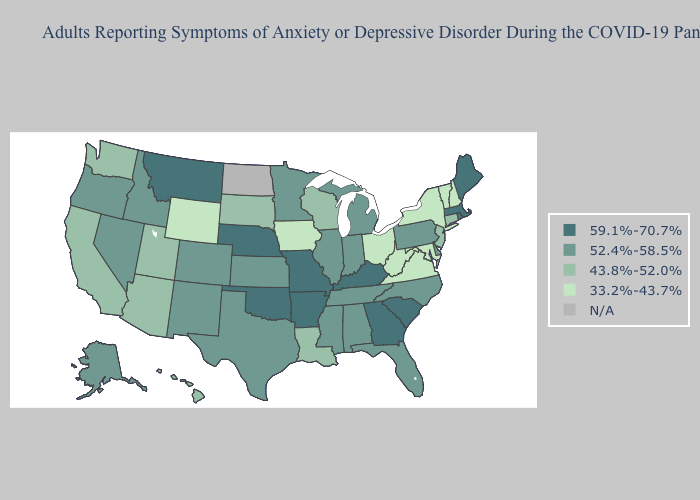What is the value of Florida?
Answer briefly. 52.4%-58.5%. What is the lowest value in the USA?
Concise answer only. 33.2%-43.7%. Does the map have missing data?
Concise answer only. Yes. Does Rhode Island have the highest value in the Northeast?
Short answer required. Yes. Among the states that border Maryland , does Delaware have the lowest value?
Concise answer only. No. Which states have the lowest value in the USA?
Answer briefly. Iowa, Maryland, New Hampshire, New York, Ohio, Vermont, Virginia, West Virginia, Wyoming. What is the value of Tennessee?
Short answer required. 52.4%-58.5%. What is the highest value in the USA?
Quick response, please. 59.1%-70.7%. What is the lowest value in the Northeast?
Give a very brief answer. 33.2%-43.7%. Which states have the lowest value in the USA?
Short answer required. Iowa, Maryland, New Hampshire, New York, Ohio, Vermont, Virginia, West Virginia, Wyoming. What is the lowest value in states that border Connecticut?
Answer briefly. 33.2%-43.7%. What is the highest value in the USA?
Give a very brief answer. 59.1%-70.7%. Name the states that have a value in the range 59.1%-70.7%?
Concise answer only. Arkansas, Georgia, Kentucky, Maine, Massachusetts, Missouri, Montana, Nebraska, Oklahoma, Rhode Island, South Carolina. What is the value of Wyoming?
Concise answer only. 33.2%-43.7%. What is the value of Alabama?
Give a very brief answer. 52.4%-58.5%. 